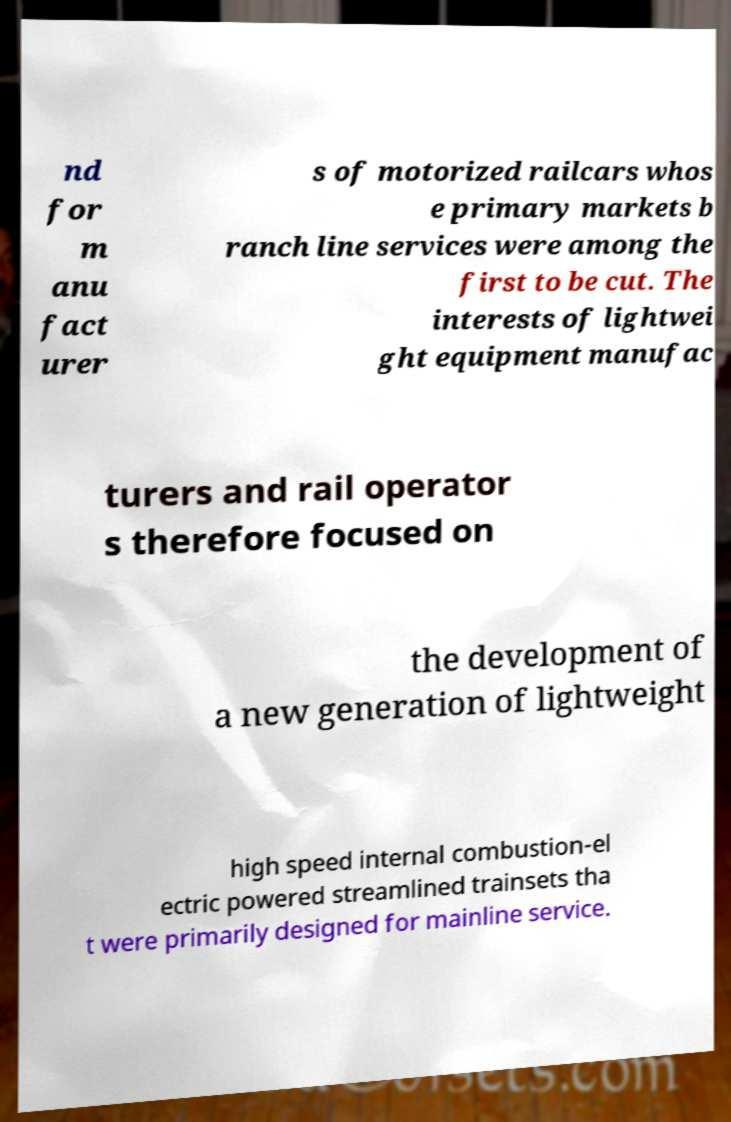I need the written content from this picture converted into text. Can you do that? nd for m anu fact urer s of motorized railcars whos e primary markets b ranch line services were among the first to be cut. The interests of lightwei ght equipment manufac turers and rail operator s therefore focused on the development of a new generation of lightweight high speed internal combustion-el ectric powered streamlined trainsets tha t were primarily designed for mainline service. 